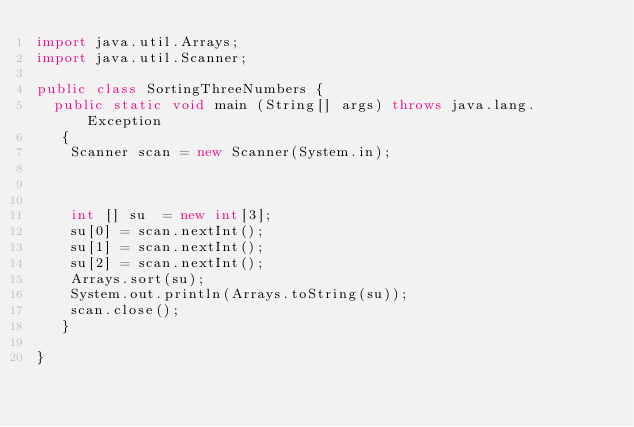<code> <loc_0><loc_0><loc_500><loc_500><_Java_>import java.util.Arrays;
import java.util.Scanner;

public class SortingThreeNumbers {
	public static void main (String[] args) throws java.lang.Exception
	 {
		Scanner scan = new Scanner(System.in);



		int [] su  = new int[3];
		su[0] = scan.nextInt();
		su[1] = scan.nextInt();
		su[2] = scan.nextInt();
		Arrays.sort(su);
		System.out.println(Arrays.toString(su));
		scan.close();
	 }

}
</code> 